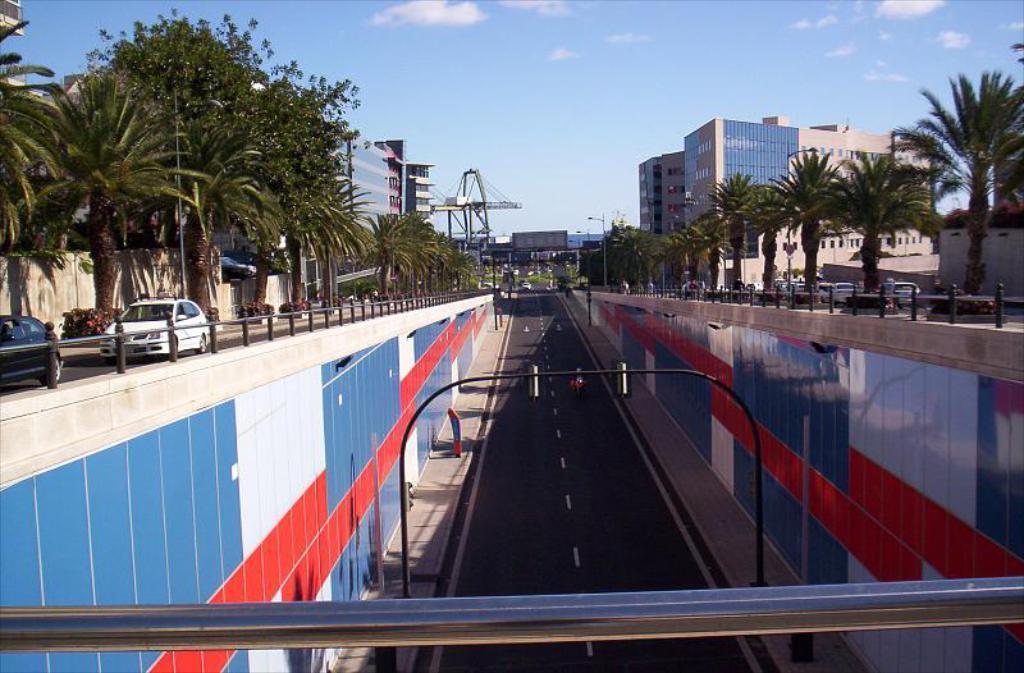Describe this image in one or two sentences. In the center of the image we can see a road, group of traffic signals. To the left side, we can see two vehicles parked on the ground a metal barricade, group of trees. In the background, we can see a group of buildings, poles and a cloudy sky. 